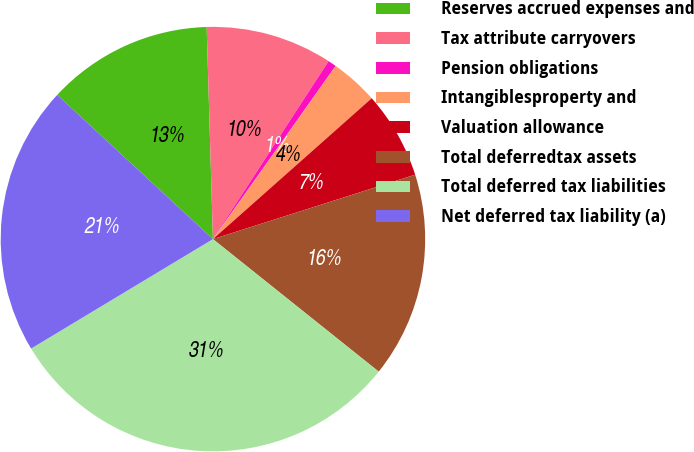Convert chart to OTSL. <chart><loc_0><loc_0><loc_500><loc_500><pie_chart><fcel>Reserves accrued expenses and<fcel>Tax attribute carryovers<fcel>Pension obligations<fcel>Intangiblesproperty and<fcel>Valuation allowance<fcel>Total deferredtax assets<fcel>Total deferred tax liabilities<fcel>Net deferred tax liability (a)<nl><fcel>12.64%<fcel>9.64%<fcel>0.64%<fcel>3.64%<fcel>6.64%<fcel>15.64%<fcel>30.64%<fcel>20.51%<nl></chart> 